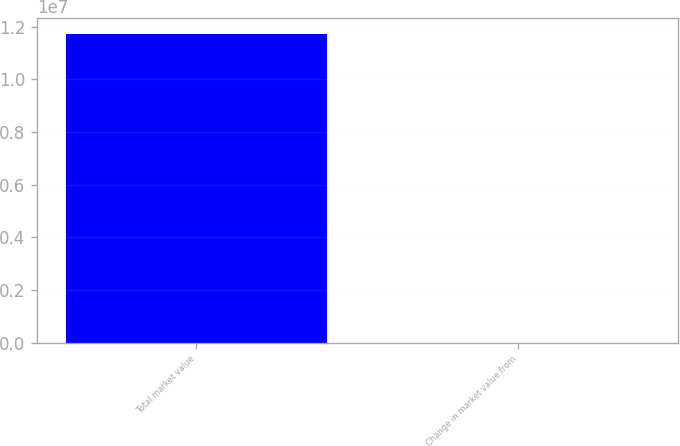Convert chart. <chart><loc_0><loc_0><loc_500><loc_500><bar_chart><fcel>Total market value<fcel>Change in market value from<nl><fcel>1.17426e+07<fcel>3.53<nl></chart> 